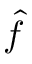Convert formula to latex. <formula><loc_0><loc_0><loc_500><loc_500>\hat { f }</formula> 